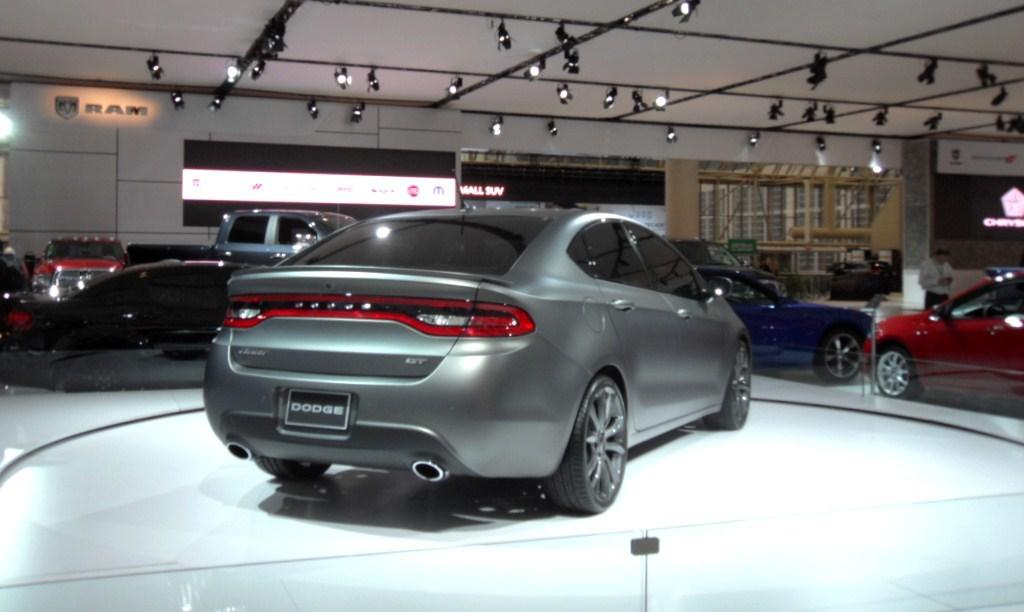What types of objects are present in the image? There are vehicles and persons in the image. What else can be seen in the image besides vehicles and persons? There are lights in the image. What type of crime is being committed in the image? There is no indication of a crime being committed in the image. Are any persons swimming in the image? There is no indication of anyone swimming in the image. 